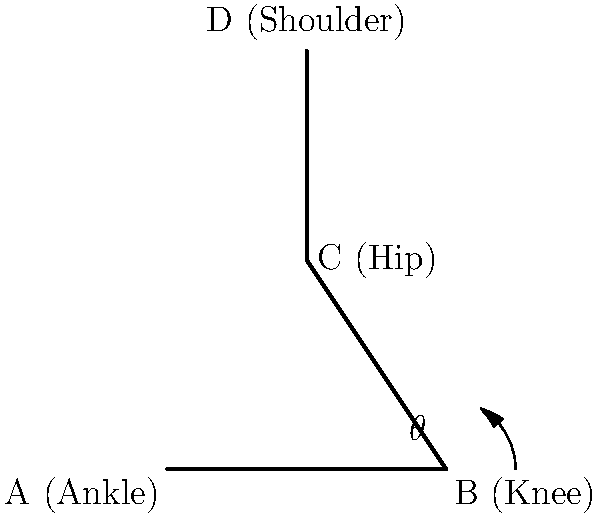As a rural clinic director, you're assessing a patient's knee function during rehabilitation. Using the simple skeletal diagram provided, calculate the magnitude of the force on the knee joint during a squat if the patient weighs 70 kg and is at a knee angle ($\theta$) of 60°. Assume the center of mass is directly above the knee and neglect the weight of the lower leg. How does this force compare to the patient's body weight? To solve this problem, we'll follow these steps:

1. Identify the forces acting on the knee:
   - The weight of the upper body (W)
   - The force on the knee joint (F)

2. Calculate the weight force:
   $W = 70 \text{ kg} \times 9.8 \text{ m/s}^2 = 686 \text{ N}$

3. Use trigonometry to find the force on the knee:
   - The force F is related to W by the angle $\theta$
   - $F = \frac{W}{\cos(\theta)}$

4. Calculate F:
   $F = \frac{686 \text{ N}}{\cos(60°)} = \frac{686}{0.5} = 1372 \text{ N}$

5. Compare to body weight:
   $\frac{1372 \text{ N}}{686 \text{ N}} \approx 2$

Therefore, the force on the knee is approximately twice the patient's body weight.
Answer: 1372 N, twice the body weight 